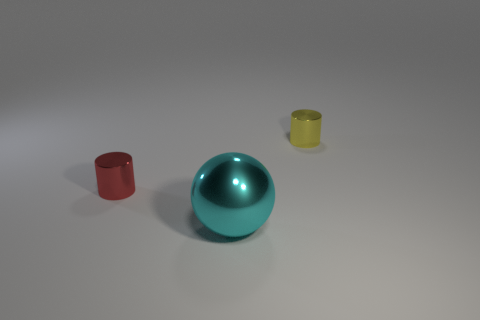Add 3 tiny yellow cylinders. How many objects exist? 6 Subtract all cylinders. How many objects are left? 1 Add 1 large gray shiny spheres. How many large gray shiny spheres exist? 1 Subtract 0 red cubes. How many objects are left? 3 Subtract all tiny green shiny cubes. Subtract all cyan spheres. How many objects are left? 2 Add 1 small red cylinders. How many small red cylinders are left? 2 